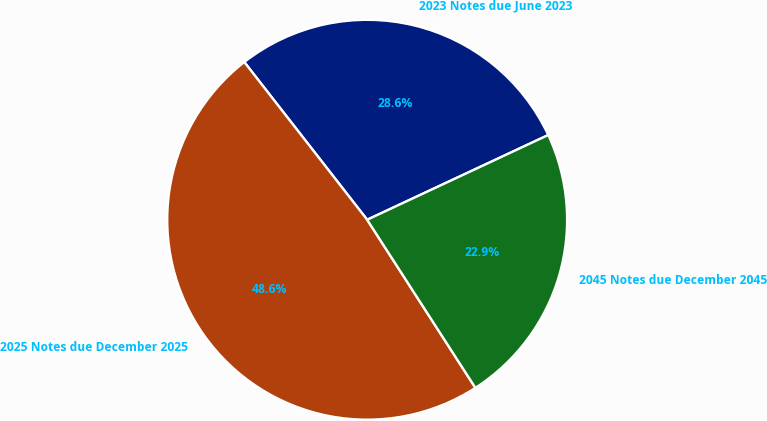<chart> <loc_0><loc_0><loc_500><loc_500><pie_chart><fcel>2023 Notes due June 2023<fcel>2025 Notes due December 2025<fcel>2045 Notes due December 2045<nl><fcel>28.57%<fcel>48.57%<fcel>22.86%<nl></chart> 